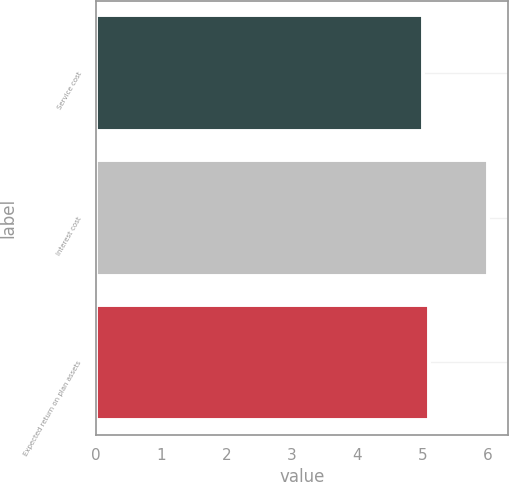Convert chart. <chart><loc_0><loc_0><loc_500><loc_500><bar_chart><fcel>Service cost<fcel>Interest cost<fcel>Expected return on plan assets<nl><fcel>5<fcel>6<fcel>5.1<nl></chart> 